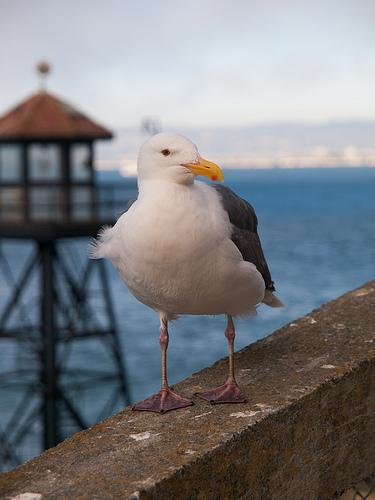What is the color of the lighthouse's roof? The roof of the lighthouse is red. Explain the scenery behind the bird. There is a lighthouse with an orange roof and a lightning rod, a brownstone wall, and clear blue ocean water behind the bird. Determine the relationship between the lighthouse and the bird in the image. The bird is standing near the lighthouse on a wall, suggesting a close proximity or interaction between the two objects. Can you enumerate the visible features of the bird standing on a wall? Webbed foot, yellow beak, skinny legs, small eye, gray feathers, folded black wing, and white breast. How does the sky look in the background of the image? The sky in the image is grey and cloudy. Analyze the emotions conveyed by the image. The image conveys a sense of calm and peacefulness, as the seagull stands near the water and the lighthouse. What is the primary bird doing in the image? The seagull is standing on an iron rail near a lighthouse with its head turned right and its webbed foot on the railing. Describe the wall that the bird is standing on. The wall is made of brownstone, with white spots and supports a dirty rusted iron rail on top. Identify the number of birds in the image. There is one bird in the image. Evaluate the image quality based on the details provided. The image is detailed and clear, providing information about various aspects of the scene, such as the bird, the wall, the lighthouse, and the water. What type of bird is present in the image? A seagull Which object is referred by the phrase "dirty rusted iron rail"? The railing at X:1, Y:410, Width:354, Height:354 Analyze the sentiment of this image. Neutral What is the color of the sky in the image? Grey and cloudy State the location and features of the lighthouse. The lighthouse is at coordinates X:0, Y:54 with a red roof, and a lightning rod. List out the colors mentioned in the image. White, gray, black, orange, red, yellow, blue, brown, silver, dark brown Detect any anomalies in the image. No anomalies detected. Does the bird have a white head and an orange beak? Yes Identify any interaction between the objects in the image. The seagull is standing on the iron railing near the lighthouse. What are the main colors in the bird's appearance? White, gray, black, orange, and yellow Describe the main objects in the image. A seagull standing on an iron railing, a lighthouse with a red roof, and a brownstone wall. Identify the most distinguishing attribute of the seagull's beak. It is orange with a red spot. Describe the visual appearance of the ocean water. The ocean water is clear blue. Is the bird standing on a wall or a rail? Both; it is standing on an iron railing along a brownstone wall. Describe the location of the bird in relation to the body of water. The bird is standing near the water on a wall. Take a closer look at the boats sailing near the lighthouse. There is no mention of any boats in the image details, so instructing the viewer to look at boats near the lighthouse would be misleading. Notice the green tree behind the white bird. There is no mention of a tree in the image details, particularly not a green one behind the bird, so instructing to notice it would be misleading. What do you think about the dolphin jumping out of the water? No dolphin or any action of a dolphin jumping is mentioned in the image details, therefore, asking for thoughts about the dolphin would be misleading. Identify the object at coordinates X:342, Y:477. A silver fence underneath the stone wall. Can you spot a dog playing with a ball near the water? There is no mention of a dog or a ball in the provided image details, so referring to a dog playing with a ball would be misleading. What color are the bird's legs? Brown Admire the beautiful sunset reflected on the ocean. There is no mention of a sunset in the image details, only clear blue ocean water, so this instruction is misleading in describing an element not present in the image. What is the position of the seagull's head? Turned right Assess the image quality of the picture. Good Contemplate the red umbrella held by a person standing near the bird. There is no mention of an umbrella, the color red, or a person holding an umbrella in the image details, so asking the viewer to contemplate this non-existent element would be misleading. 